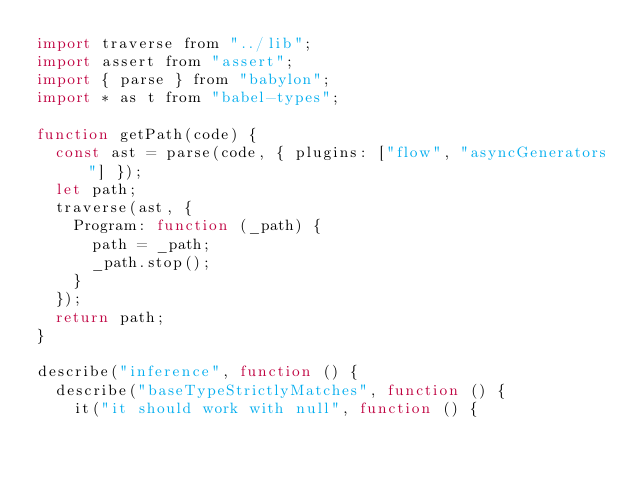<code> <loc_0><loc_0><loc_500><loc_500><_JavaScript_>import traverse from "../lib";
import assert from "assert";
import { parse } from "babylon";
import * as t from "babel-types";

function getPath(code) {
  const ast = parse(code, { plugins: ["flow", "asyncGenerators"] });
  let path;
  traverse(ast, {
    Program: function (_path) {
      path = _path;
      _path.stop();
    }
  });
  return path;
}

describe("inference", function () {
  describe("baseTypeStrictlyMatches", function () {
    it("it should work with null", function () {</code> 